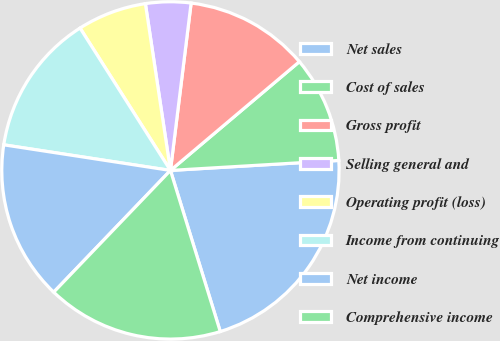Convert chart to OTSL. <chart><loc_0><loc_0><loc_500><loc_500><pie_chart><fcel>Net sales<fcel>Cost of sales<fcel>Gross profit<fcel>Selling general and<fcel>Operating profit (loss)<fcel>Income from continuing<fcel>Net income<fcel>Comprehensive income<nl><fcel>21.17%<fcel>10.21%<fcel>11.89%<fcel>4.33%<fcel>6.63%<fcel>13.57%<fcel>15.26%<fcel>16.94%<nl></chart> 